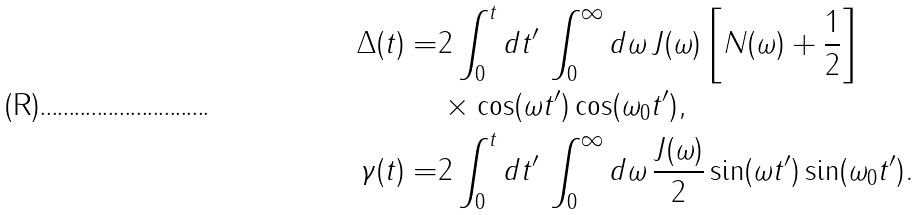<formula> <loc_0><loc_0><loc_500><loc_500>\Delta ( t ) = & 2 \int _ { 0 } ^ { t } d t ^ { \prime } \, \int _ { 0 } ^ { \infty } d \omega \, J ( \omega ) \left [ N ( \omega ) + \frac { 1 } { 2 } \right ] \\ & \times \cos ( \omega t ^ { \prime } ) \cos ( \omega _ { 0 } t ^ { \prime } ) , \\ \gamma ( t ) = & 2 \int _ { 0 } ^ { t } d t ^ { \prime } \, \int _ { 0 } ^ { \infty } d \omega \, \frac { J ( \omega ) } { 2 } \sin ( \omega t ^ { \prime } ) \sin ( \omega _ { 0 } t ^ { \prime } ) .</formula> 